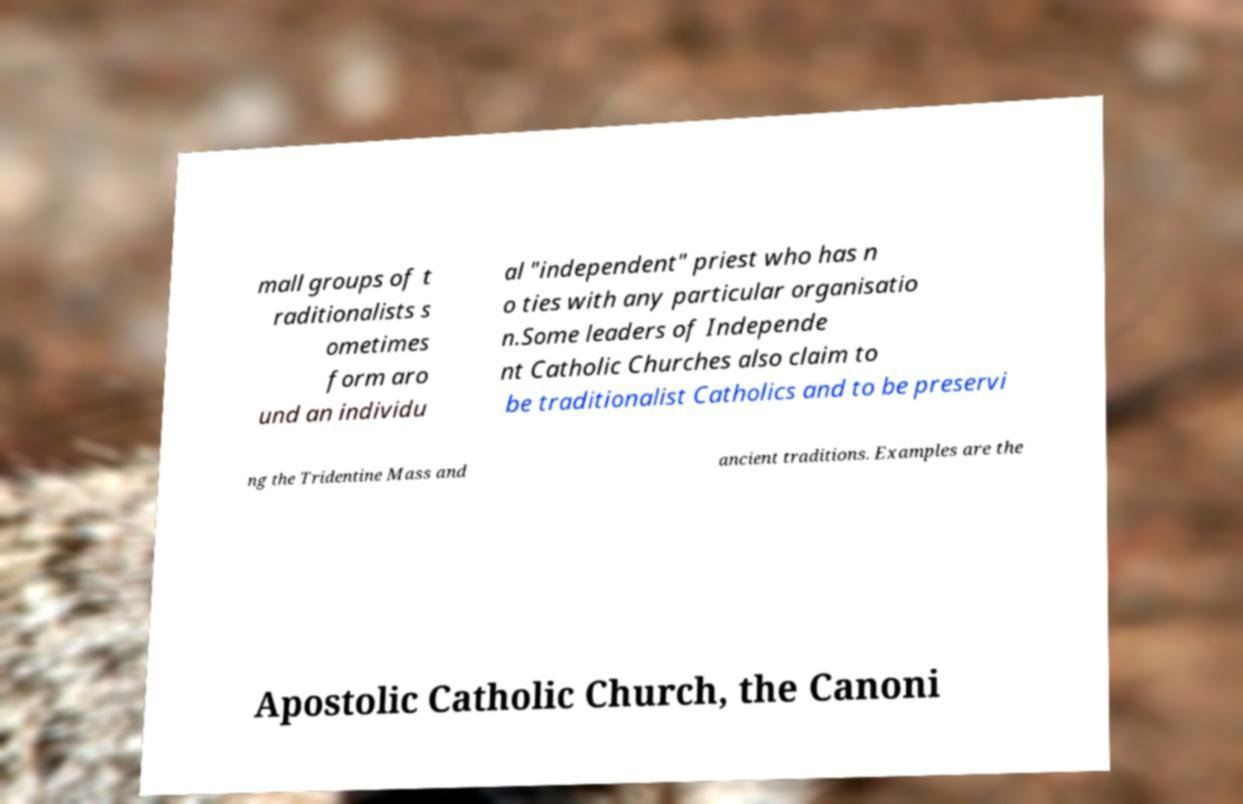Can you accurately transcribe the text from the provided image for me? mall groups of t raditionalists s ometimes form aro und an individu al "independent" priest who has n o ties with any particular organisatio n.Some leaders of Independe nt Catholic Churches also claim to be traditionalist Catholics and to be preservi ng the Tridentine Mass and ancient traditions. Examples are the Apostolic Catholic Church, the Canoni 